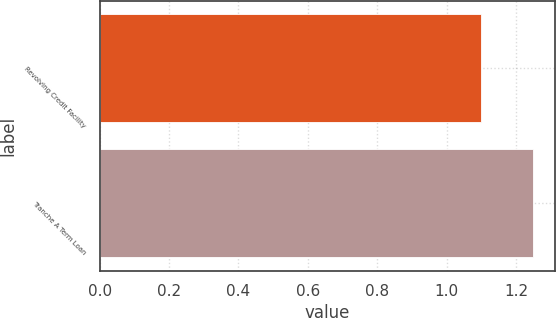Convert chart. <chart><loc_0><loc_0><loc_500><loc_500><bar_chart><fcel>Revolving Credit Facility<fcel>Tranche A Term Loan<nl><fcel>1.1<fcel>1.25<nl></chart> 